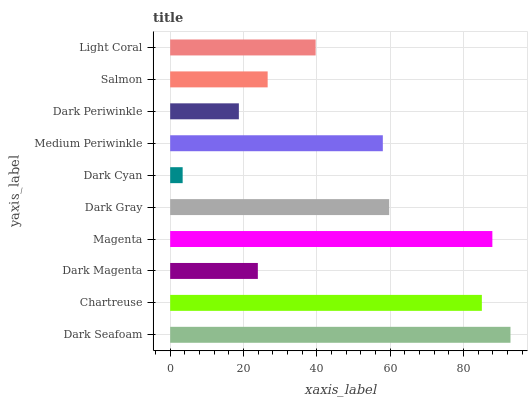Is Dark Cyan the minimum?
Answer yes or no. Yes. Is Dark Seafoam the maximum?
Answer yes or no. Yes. Is Chartreuse the minimum?
Answer yes or no. No. Is Chartreuse the maximum?
Answer yes or no. No. Is Dark Seafoam greater than Chartreuse?
Answer yes or no. Yes. Is Chartreuse less than Dark Seafoam?
Answer yes or no. Yes. Is Chartreuse greater than Dark Seafoam?
Answer yes or no. No. Is Dark Seafoam less than Chartreuse?
Answer yes or no. No. Is Medium Periwinkle the high median?
Answer yes or no. Yes. Is Light Coral the low median?
Answer yes or no. Yes. Is Dark Seafoam the high median?
Answer yes or no. No. Is Salmon the low median?
Answer yes or no. No. 